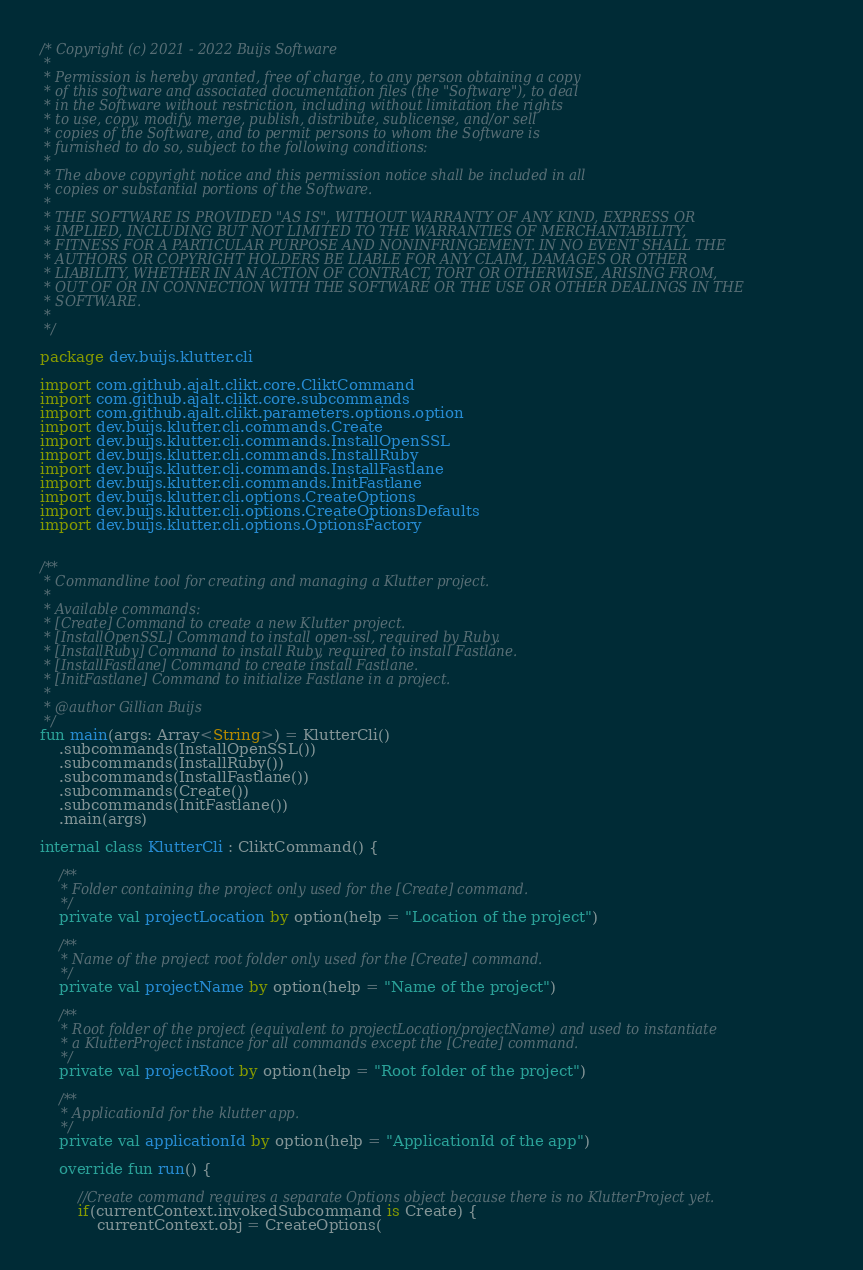<code> <loc_0><loc_0><loc_500><loc_500><_Kotlin_>/* Copyright (c) 2021 - 2022 Buijs Software
 *
 * Permission is hereby granted, free of charge, to any person obtaining a copy
 * of this software and associated documentation files (the "Software"), to deal
 * in the Software without restriction, including without limitation the rights
 * to use, copy, modify, merge, publish, distribute, sublicense, and/or sell
 * copies of the Software, and to permit persons to whom the Software is
 * furnished to do so, subject to the following conditions:
 *
 * The above copyright notice and this permission notice shall be included in all
 * copies or substantial portions of the Software.
 *
 * THE SOFTWARE IS PROVIDED "AS IS", WITHOUT WARRANTY OF ANY KIND, EXPRESS OR
 * IMPLIED, INCLUDING BUT NOT LIMITED TO THE WARRANTIES OF MERCHANTABILITY,
 * FITNESS FOR A PARTICULAR PURPOSE AND NONINFRINGEMENT. IN NO EVENT SHALL THE
 * AUTHORS OR COPYRIGHT HOLDERS BE LIABLE FOR ANY CLAIM, DAMAGES OR OTHER
 * LIABILITY, WHETHER IN AN ACTION OF CONTRACT, TORT OR OTHERWISE, ARISING FROM,
 * OUT OF OR IN CONNECTION WITH THE SOFTWARE OR THE USE OR OTHER DEALINGS IN THE
 * SOFTWARE.
 *
 */

package dev.buijs.klutter.cli

import com.github.ajalt.clikt.core.CliktCommand
import com.github.ajalt.clikt.core.subcommands
import com.github.ajalt.clikt.parameters.options.option
import dev.buijs.klutter.cli.commands.Create
import dev.buijs.klutter.cli.commands.InstallOpenSSL
import dev.buijs.klutter.cli.commands.InstallRuby
import dev.buijs.klutter.cli.commands.InstallFastlane
import dev.buijs.klutter.cli.commands.InitFastlane
import dev.buijs.klutter.cli.options.CreateOptions
import dev.buijs.klutter.cli.options.CreateOptionsDefaults
import dev.buijs.klutter.cli.options.OptionsFactory


/**
 * Commandline tool for creating and managing a Klutter project.
 *
 * Available commands:
 * [Create] Command to create a new Klutter project.
 * [InstallOpenSSL] Command to install open-ssl, required by Ruby.
 * [InstallRuby] Command to install Ruby, required to install Fastlane.
 * [InstallFastlane] Command to create install Fastlane.
 * [InitFastlane] Command to initialize Fastlane in a project.
 *
 * @author Gillian Buijs
 */
fun main(args: Array<String>) = KlutterCli()
    .subcommands(InstallOpenSSL())
    .subcommands(InstallRuby())
    .subcommands(InstallFastlane())
    .subcommands(Create())
    .subcommands(InitFastlane())
    .main(args)

internal class KlutterCli : CliktCommand() {

    /**
     * Folder containing the project only used for the [Create] command.
     */
    private val projectLocation by option(help = "Location of the project")

    /**
     * Name of the project root folder only used for the [Create] command.
     */
    private val projectName by option(help = "Name of the project")

    /**
     * Root folder of the project (equivalent to projectLocation/projectName) and used to instantiate
     * a KlutterProject instance for all commands except the [Create] command.
     */
    private val projectRoot by option(help = "Root folder of the project")

    /**
     * ApplicationId for the klutter app.
     */
    private val applicationId by option(help = "ApplicationId of the app")

    override fun run() {

        //Create command requires a separate Options object because there is no KlutterProject yet.
        if(currentContext.invokedSubcommand is Create) {
            currentContext.obj = CreateOptions(</code> 